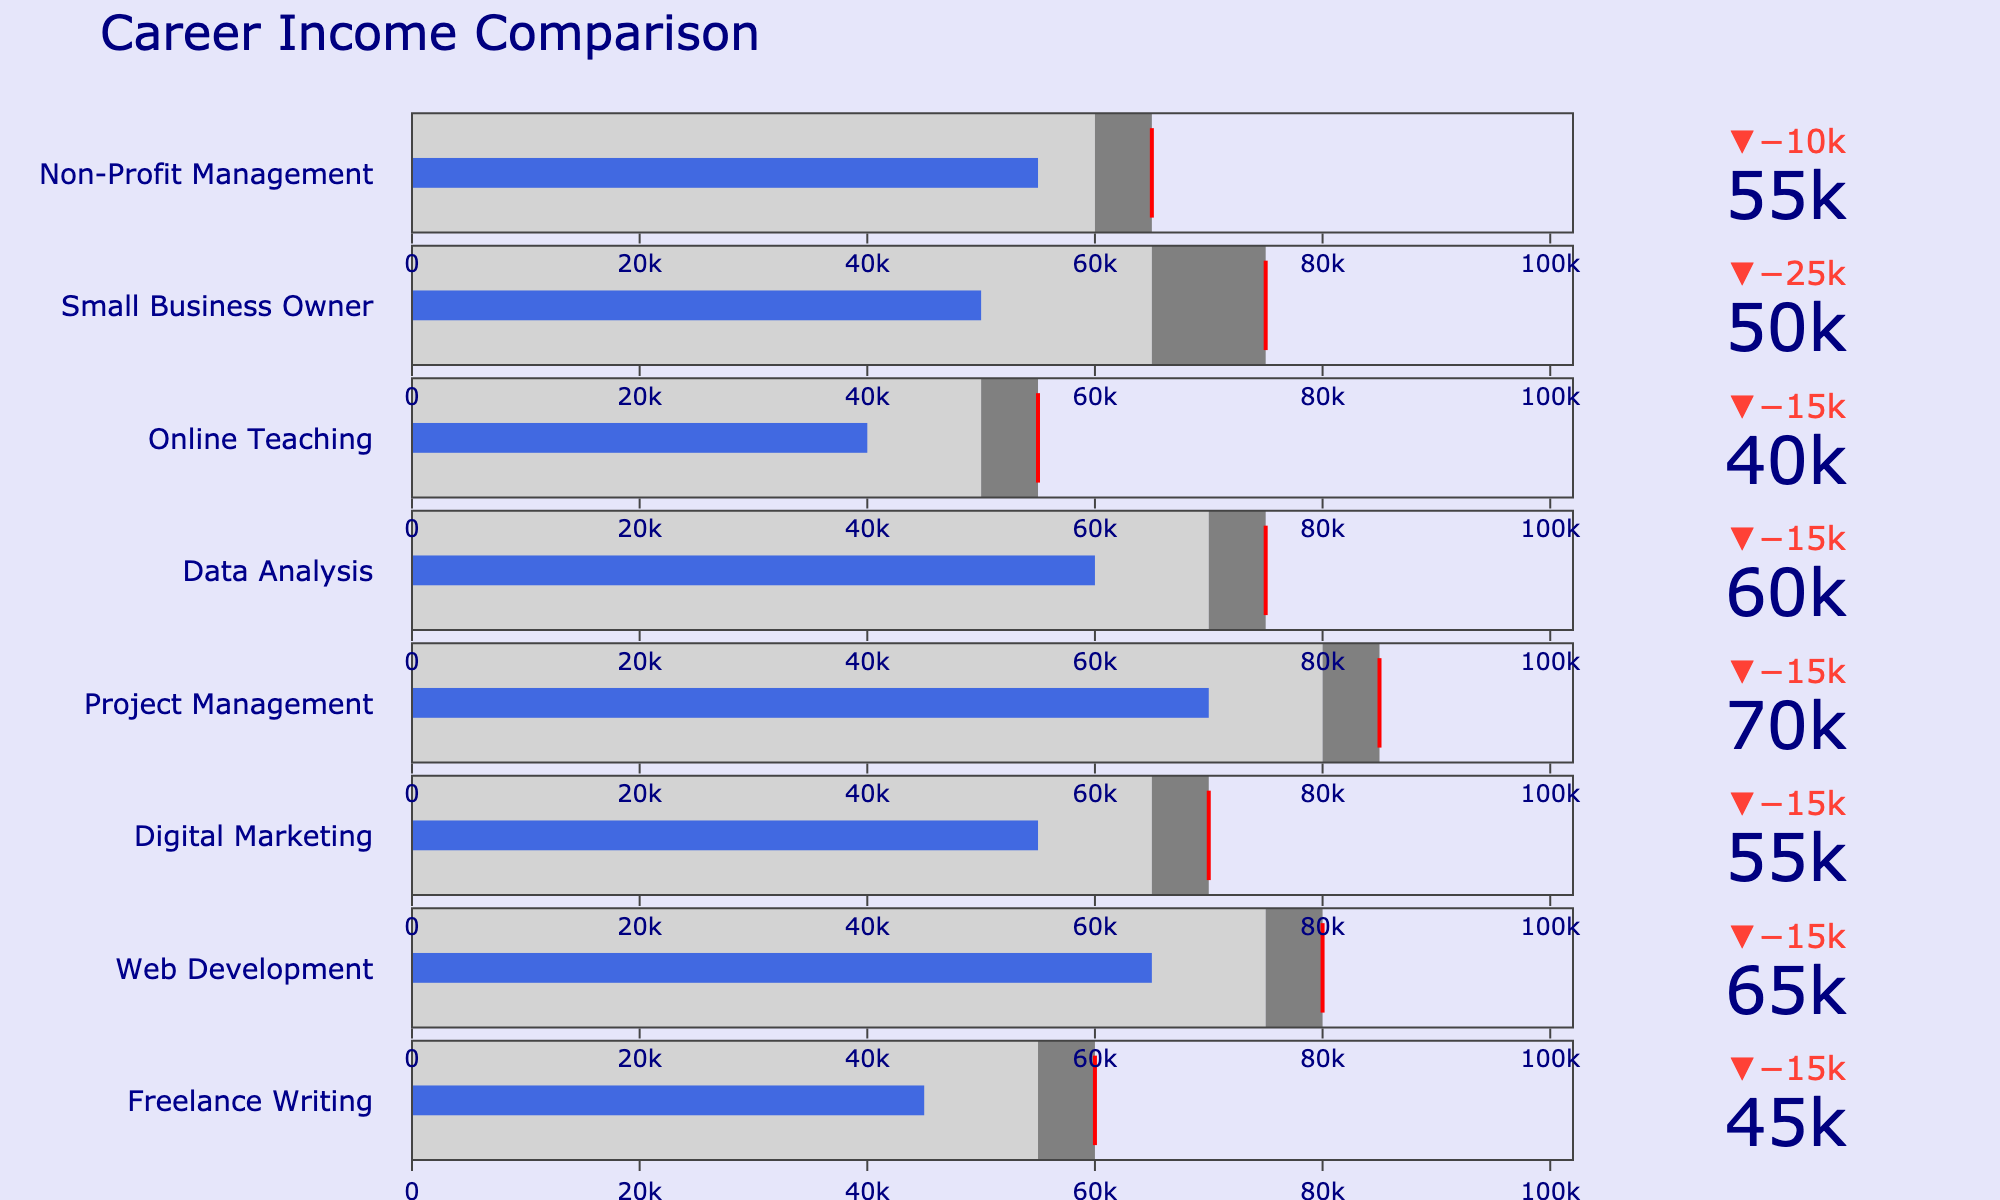What's the target income for a career in Digital Marketing? The bullet chart shows the target incomes as the threshold values marked by a red line. The target income for Digital Marketing is 70,000.
Answer: 70,000 Which career has the highest actual income? To determine which career has the highest actual income, compare the actual income values of each career. The highest actual income is for Project Management at 70,000.
Answer: Project Management How does the actual income for Freelance Writing compare to its target income? Compare the position of the actual income bar to the target income line for Freelance Writing. The actual income is 45,000, which is less than the target income of 60,000.
Answer: Less than What's the average income for Small Business Owner? The bullet chart shows the average incomes as the first step in the gauge. For Small Business Owner, the average income is 65,000.
Answer: 65,000 For which careers does the actual income exceed the average income? Analyze the bullet chart to determine which careers have actual income bars that extend past the light gray area (indicating average income). Web Development, Digital Marketing, Project Management, and Data Analysis have actual incomes exceeding their respective average incomes.
Answer: Web Development, Digital Marketing, Project Management, Data Analysis What's the difference between actual and target income for Web Development? Subtract the actual income from the target income for Web Development. The actual income is 65,000 and the target income is 80,000. The difference is 80,000 - 65,000.
Answer: 15,000 Is the actual income for Online Teaching closer to its average income or target income? Compare the actual income of 40,000 to both the average income of 50,000 and the target income of 55,000. The actual income is closer to the average income (difference of 10,000) than to the target income (difference of 15,000).
Answer: Closer to average income Which career has the smallest gap between its actual and target income? Calculate the differences between actual and target incomes for each career and identify the smallest value. The smallest gap is for Non-Profit Management, with a difference of 10,000 (55,000 actual and 65,000 target).
Answer: Non-Profit Management By how much does the actual income for Data Analysis fall short of the target income? Subtract the actual income from the target income for Data Analysis. The actual income is 60,000 and the target income is 75,000. The shortfall is 75,000 - 60,000 = 15,000.
Answer: 15,000 